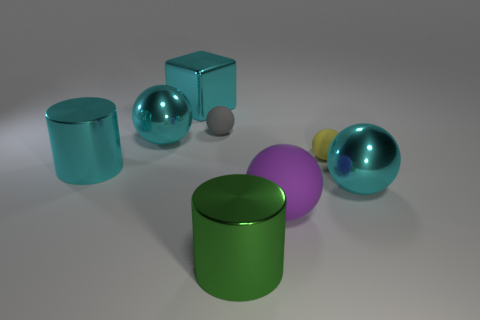What color is the big cylinder behind the shiny ball that is in front of the cyan sphere behind the big cyan shiny cylinder?
Offer a terse response. Cyan. What number of large shiny balls are the same color as the block?
Your answer should be very brief. 2. What number of large objects are purple rubber balls or cylinders?
Your answer should be compact. 3. Is there a gray matte thing of the same shape as the purple thing?
Give a very brief answer. Yes. Is the shape of the tiny gray thing the same as the green thing?
Your answer should be very brief. No. What is the color of the big metallic ball that is in front of the tiny object right of the tiny gray rubber thing?
Keep it short and to the point. Cyan. The other matte object that is the same size as the gray rubber object is what color?
Your answer should be compact. Yellow. What number of metallic objects are either big cyan spheres or large purple things?
Your answer should be very brief. 2. There is a small ball that is on the right side of the large rubber sphere; how many big cyan balls are behind it?
Keep it short and to the point. 1. There is a shiny cylinder that is the same color as the metallic block; what size is it?
Keep it short and to the point. Large. 